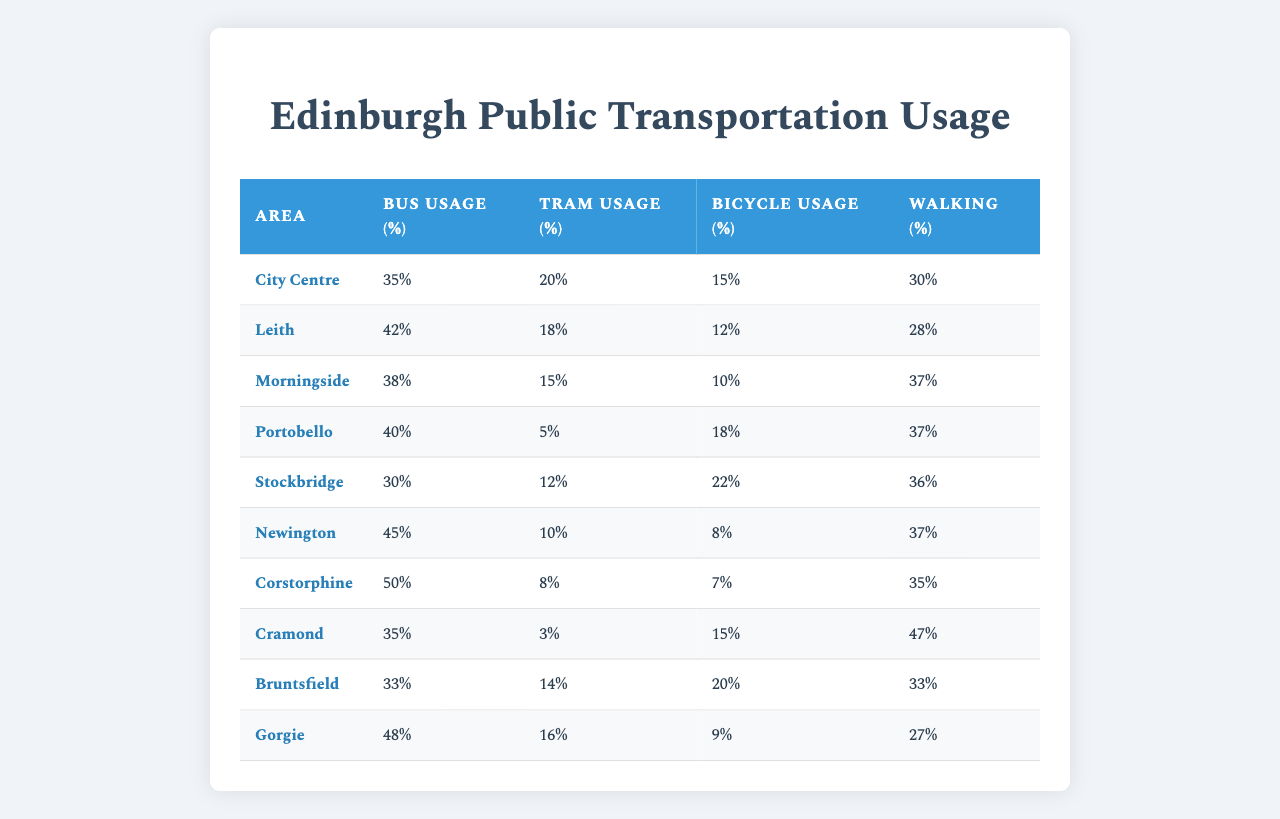What area has the highest percentage of bus usage? By examining the "Bus Usage (%)" column, we can see that Newington has the highest percentage of bus usage at 45%.
Answer: Newington What is the total percentage of transportation modes for the area Portobello? For Portobello, the bus usage is 40%, tram usage is 5%, bicycle usage is 18%, and walking is 37%. Adding these together gives 40 + 5 + 18 + 37 = 100%.
Answer: 100% Is the tram usage in Morningside greater than in Gorgie? Morningside has a tram usage of 15%, while Gorgie has 16%. Since 15% is less than 16%, the statement is false.
Answer: No What area has the lowest tram usage percentage, and what is that percentage? By reviewing the "Tram Usage (%)" column, we can see that Cramond has the lowest percentage at 3%.
Answer: Cramond, 3% Which area has the highest walking percentage, and what is the percentage? Looking at the "Walking (%)" column, Cramond has the highest walking percentage at 47%.
Answer: Cramond, 47% Calculate the average bicycle usage percentage across all areas. To find the average bicycle usage, we sum the bicycle usages: 15 + 12 + 10 + 18 + 22 + 8 + 7 + 15 + 20 + 9 =  142%. Dividing by the number of areas (10) gives an average of 142/10 = 14.2%.
Answer: 14.2% What is the difference between the bus usage of City Centre and Newington? The bus usage for City Centre is 35%, while for Newington it is 45%. The difference is 45 - 35 = 10%.
Answer: 10% Are more people using bicycles than trams in the City Centre? In the City Centre, bus usage is 35% (bus), 20% (tram), 15% (bicycle). Since 15% for bicycles is less than 20% for trams, the statement is false.
Answer: No Which areas have a bus usage percentage above 40%? Reviewing the "Bus Usage (%)" column, Leith (42%), Newington (45%), and Corstorphine (50%) all have percentages above 40%.
Answer: Leith, Newington, Corstorphine If you combine the walking and bicycle usage percentages for Stockbridge, what would be the total? Stockbridge has a walking percentage of 36% and bicycle usage of 22%. Adding these gives 36 + 22 = 58%.
Answer: 58% 